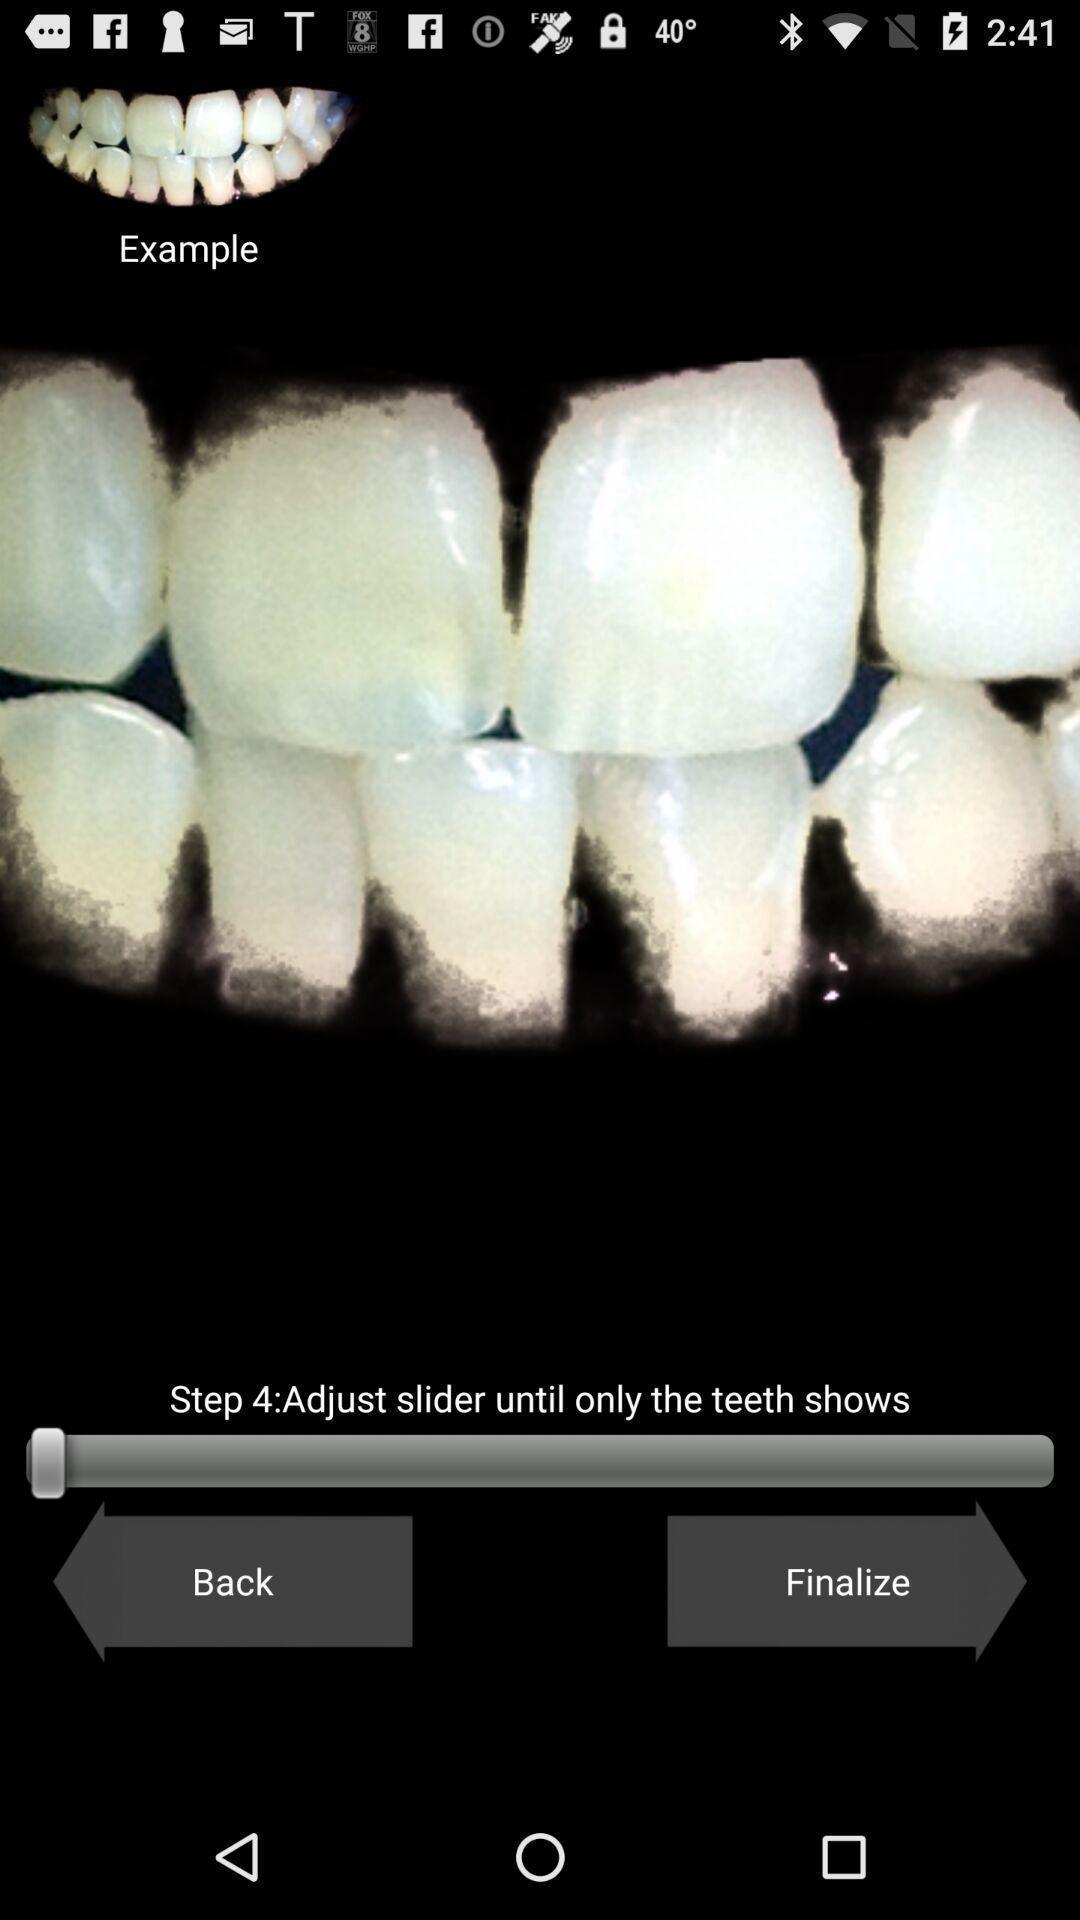Describe the key features of this screenshot. Teeth image is displaying with different controls. 